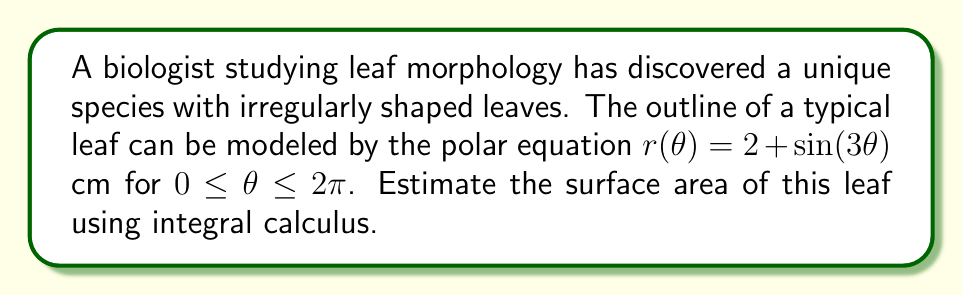Can you solve this math problem? To estimate the surface area of the irregularly shaped leaf, we can use the formula for the area of a region in polar coordinates:

$$A = \frac{1}{2} \int_{0}^{2\pi} [r(\theta)]^2 d\theta$$

Step 1: Substitute the given function $r(\theta) = 2 + \sin(3\theta)$ into the formula:

$$A = \frac{1}{2} \int_{0}^{2\pi} [2 + \sin(3\theta)]^2 d\theta$$

Step 2: Expand the squared term:

$$A = \frac{1}{2} \int_{0}^{2\pi} [4 + 4\sin(3\theta) + \sin^2(3\theta)] d\theta$$

Step 3: Use the trigonometric identity $\sin^2(x) = \frac{1 - \cos(2x)}{2}$:

$$A = \frac{1}{2} \int_{0}^{2\pi} [4 + 4\sin(3\theta) + \frac{1 - \cos(6\theta)}{2}] d\theta$$

Step 4: Simplify:

$$A = \frac{1}{2} \int_{0}^{2\pi} [4.5 + 4\sin(3\theta) - \frac{1}{2}\cos(6\theta)] d\theta$$

Step 5: Integrate each term:

$$A = \frac{1}{2} [4.5\theta - \frac{4}{3}\cos(3\theta) - \frac{1}{12}\sin(6\theta)]_{0}^{2\pi}$$

Step 6: Evaluate the integral:

$$A = \frac{1}{2} [(4.5 \cdot 2\pi - 0) - (\frac{4}{3} \cdot 1 - \frac{4}{3} \cdot 1) - (0 - 0)]$$

Step 7: Simplify:

$$A = \frac{1}{2} \cdot 4.5 \cdot 2\pi = 4.5\pi$$

Therefore, the estimated surface area of the leaf is $4.5\pi$ square centimeters.
Answer: $4.5\pi \text{ cm}^2$ 